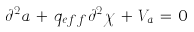<formula> <loc_0><loc_0><loc_500><loc_500>\partial ^ { 2 } a \, + \, q _ { e f f } \partial ^ { 2 } \chi \, + \, V _ { a } \, = \, 0</formula> 